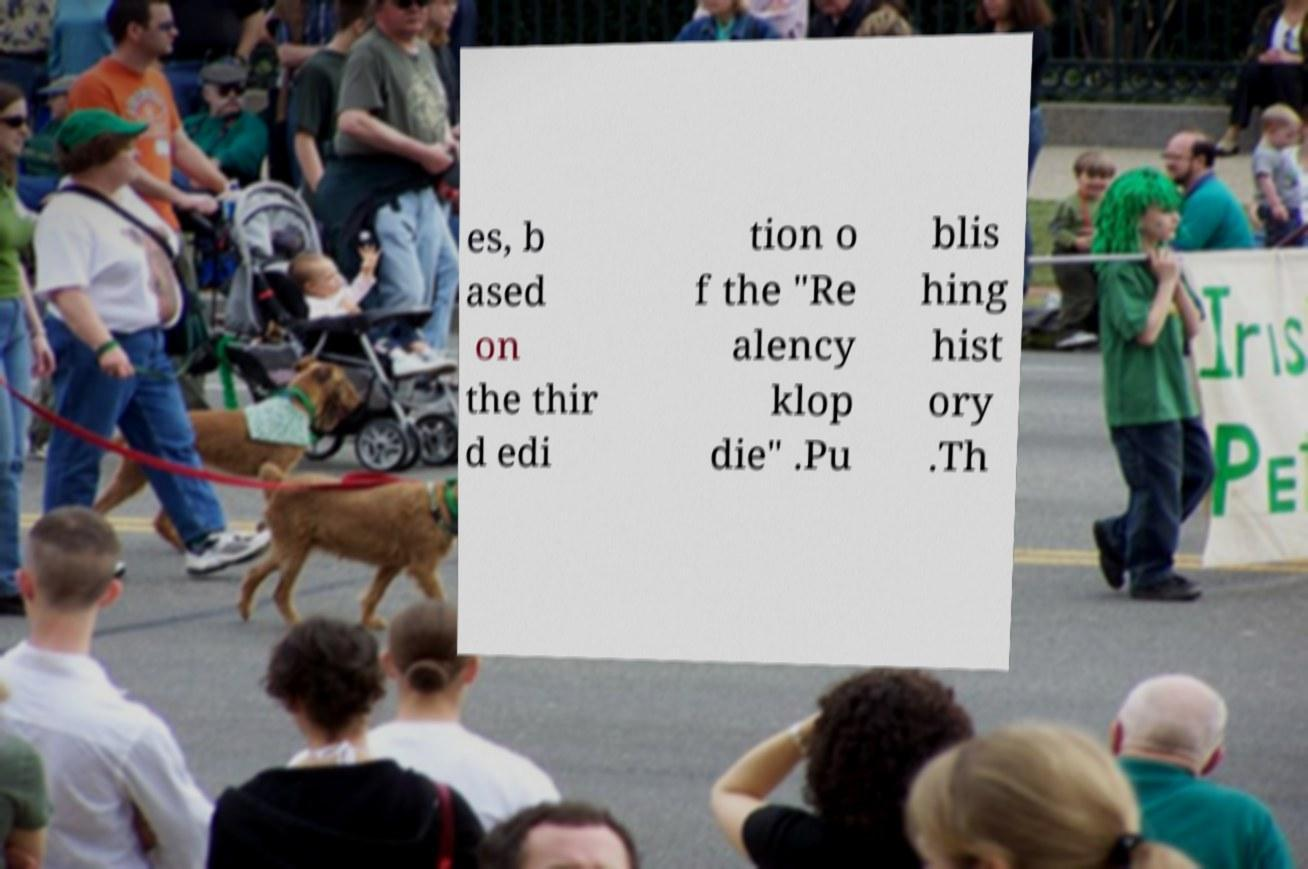Could you assist in decoding the text presented in this image and type it out clearly? es, b ased on the thir d edi tion o f the "Re alency klop die" .Pu blis hing hist ory .Th 